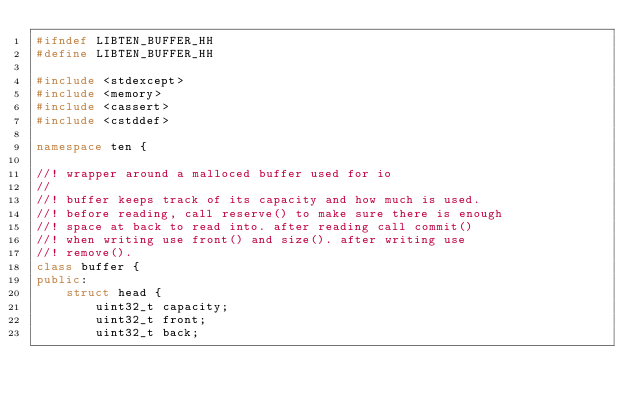<code> <loc_0><loc_0><loc_500><loc_500><_C++_>#ifndef LIBTEN_BUFFER_HH
#define LIBTEN_BUFFER_HH

#include <stdexcept>
#include <memory>
#include <cassert>
#include <cstddef>

namespace ten {

//! wrapper around a malloced buffer used for io
//
//! buffer keeps track of its capacity and how much is used.
//! before reading, call reserve() to make sure there is enough
//! space at back to read into. after reading call commit()
//! when writing use front() and size(). after writing use
//! remove().
class buffer {
public:
    struct head {
        uint32_t capacity;
        uint32_t front;
        uint32_t back;</code> 